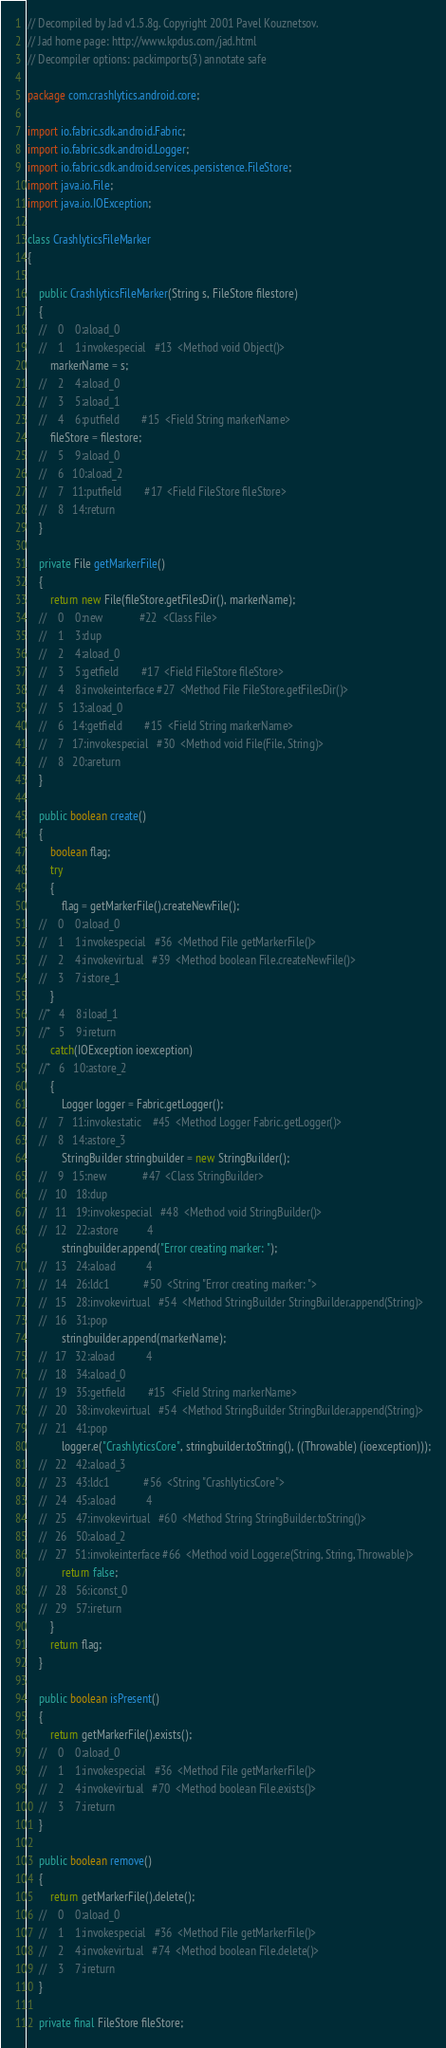Convert code to text. <code><loc_0><loc_0><loc_500><loc_500><_Java_>// Decompiled by Jad v1.5.8g. Copyright 2001 Pavel Kouznetsov.
// Jad home page: http://www.kpdus.com/jad.html
// Decompiler options: packimports(3) annotate safe 

package com.crashlytics.android.core;

import io.fabric.sdk.android.Fabric;
import io.fabric.sdk.android.Logger;
import io.fabric.sdk.android.services.persistence.FileStore;
import java.io.File;
import java.io.IOException;

class CrashlyticsFileMarker
{

	public CrashlyticsFileMarker(String s, FileStore filestore)
	{
	//    0    0:aload_0         
	//    1    1:invokespecial   #13  <Method void Object()>
		markerName = s;
	//    2    4:aload_0         
	//    3    5:aload_1         
	//    4    6:putfield        #15  <Field String markerName>
		fileStore = filestore;
	//    5    9:aload_0         
	//    6   10:aload_2         
	//    7   11:putfield        #17  <Field FileStore fileStore>
	//    8   14:return          
	}

	private File getMarkerFile()
	{
		return new File(fileStore.getFilesDir(), markerName);
	//    0    0:new             #22  <Class File>
	//    1    3:dup             
	//    2    4:aload_0         
	//    3    5:getfield        #17  <Field FileStore fileStore>
	//    4    8:invokeinterface #27  <Method File FileStore.getFilesDir()>
	//    5   13:aload_0         
	//    6   14:getfield        #15  <Field String markerName>
	//    7   17:invokespecial   #30  <Method void File(File, String)>
	//    8   20:areturn         
	}

	public boolean create()
	{
		boolean flag;
		try
		{
			flag = getMarkerFile().createNewFile();
	//    0    0:aload_0         
	//    1    1:invokespecial   #36  <Method File getMarkerFile()>
	//    2    4:invokevirtual   #39  <Method boolean File.createNewFile()>
	//    3    7:istore_1        
		}
	//*   4    8:iload_1         
	//*   5    9:ireturn         
		catch(IOException ioexception)
	//*   6   10:astore_2        
		{
			Logger logger = Fabric.getLogger();
	//    7   11:invokestatic    #45  <Method Logger Fabric.getLogger()>
	//    8   14:astore_3        
			StringBuilder stringbuilder = new StringBuilder();
	//    9   15:new             #47  <Class StringBuilder>
	//   10   18:dup             
	//   11   19:invokespecial   #48  <Method void StringBuilder()>
	//   12   22:astore          4
			stringbuilder.append("Error creating marker: ");
	//   13   24:aload           4
	//   14   26:ldc1            #50  <String "Error creating marker: ">
	//   15   28:invokevirtual   #54  <Method StringBuilder StringBuilder.append(String)>
	//   16   31:pop             
			stringbuilder.append(markerName);
	//   17   32:aload           4
	//   18   34:aload_0         
	//   19   35:getfield        #15  <Field String markerName>
	//   20   38:invokevirtual   #54  <Method StringBuilder StringBuilder.append(String)>
	//   21   41:pop             
			logger.e("CrashlyticsCore", stringbuilder.toString(), ((Throwable) (ioexception)));
	//   22   42:aload_3         
	//   23   43:ldc1            #56  <String "CrashlyticsCore">
	//   24   45:aload           4
	//   25   47:invokevirtual   #60  <Method String StringBuilder.toString()>
	//   26   50:aload_2         
	//   27   51:invokeinterface #66  <Method void Logger.e(String, String, Throwable)>
			return false;
	//   28   56:iconst_0        
	//   29   57:ireturn         
		}
		return flag;
	}

	public boolean isPresent()
	{
		return getMarkerFile().exists();
	//    0    0:aload_0         
	//    1    1:invokespecial   #36  <Method File getMarkerFile()>
	//    2    4:invokevirtual   #70  <Method boolean File.exists()>
	//    3    7:ireturn         
	}

	public boolean remove()
	{
		return getMarkerFile().delete();
	//    0    0:aload_0         
	//    1    1:invokespecial   #36  <Method File getMarkerFile()>
	//    2    4:invokevirtual   #74  <Method boolean File.delete()>
	//    3    7:ireturn         
	}

	private final FileStore fileStore;</code> 